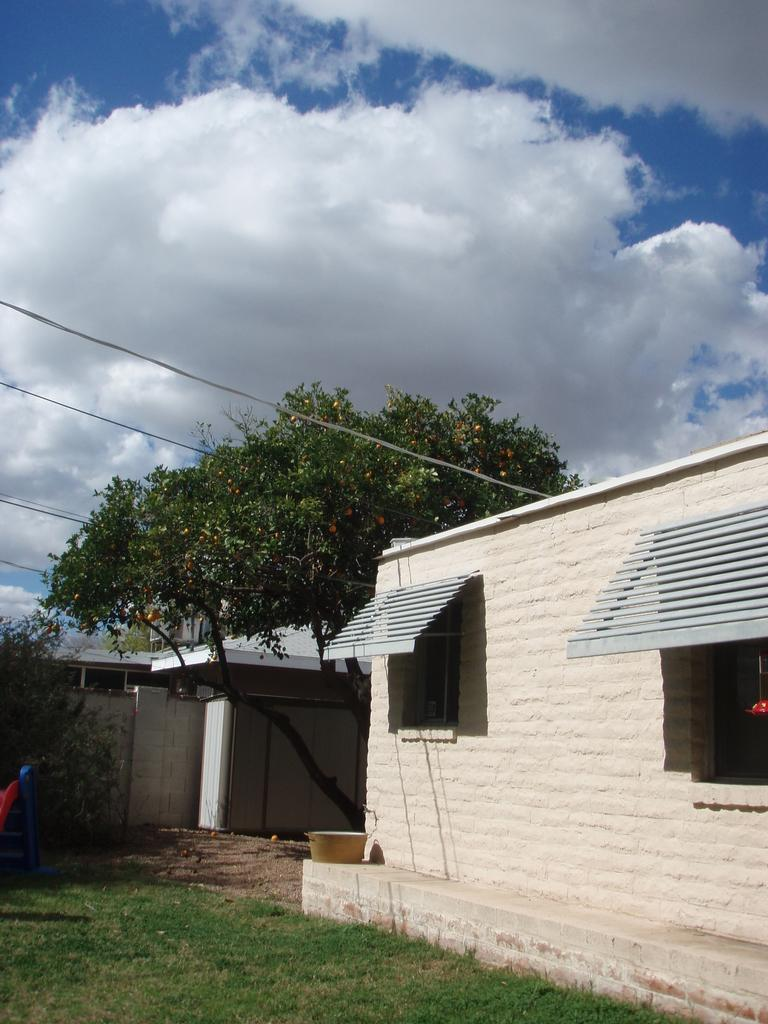What is located in the center of the image? There are houses and trees in the center of the image. What type of vegetation can be seen at the bottom of the image? There is grass and sand at the bottom of the image. What object is present at the bottom of the image? There is a basket at the bottom of the image. What is visible at the top of the image? The sky is visible at the top of the image, and there are wires present as well. Can you tell me how many family members are visible in the image? There is no reference to a family or any family members in the image. What type of straw is being used by the giants in the image? There are no giants or straw present in the image. 